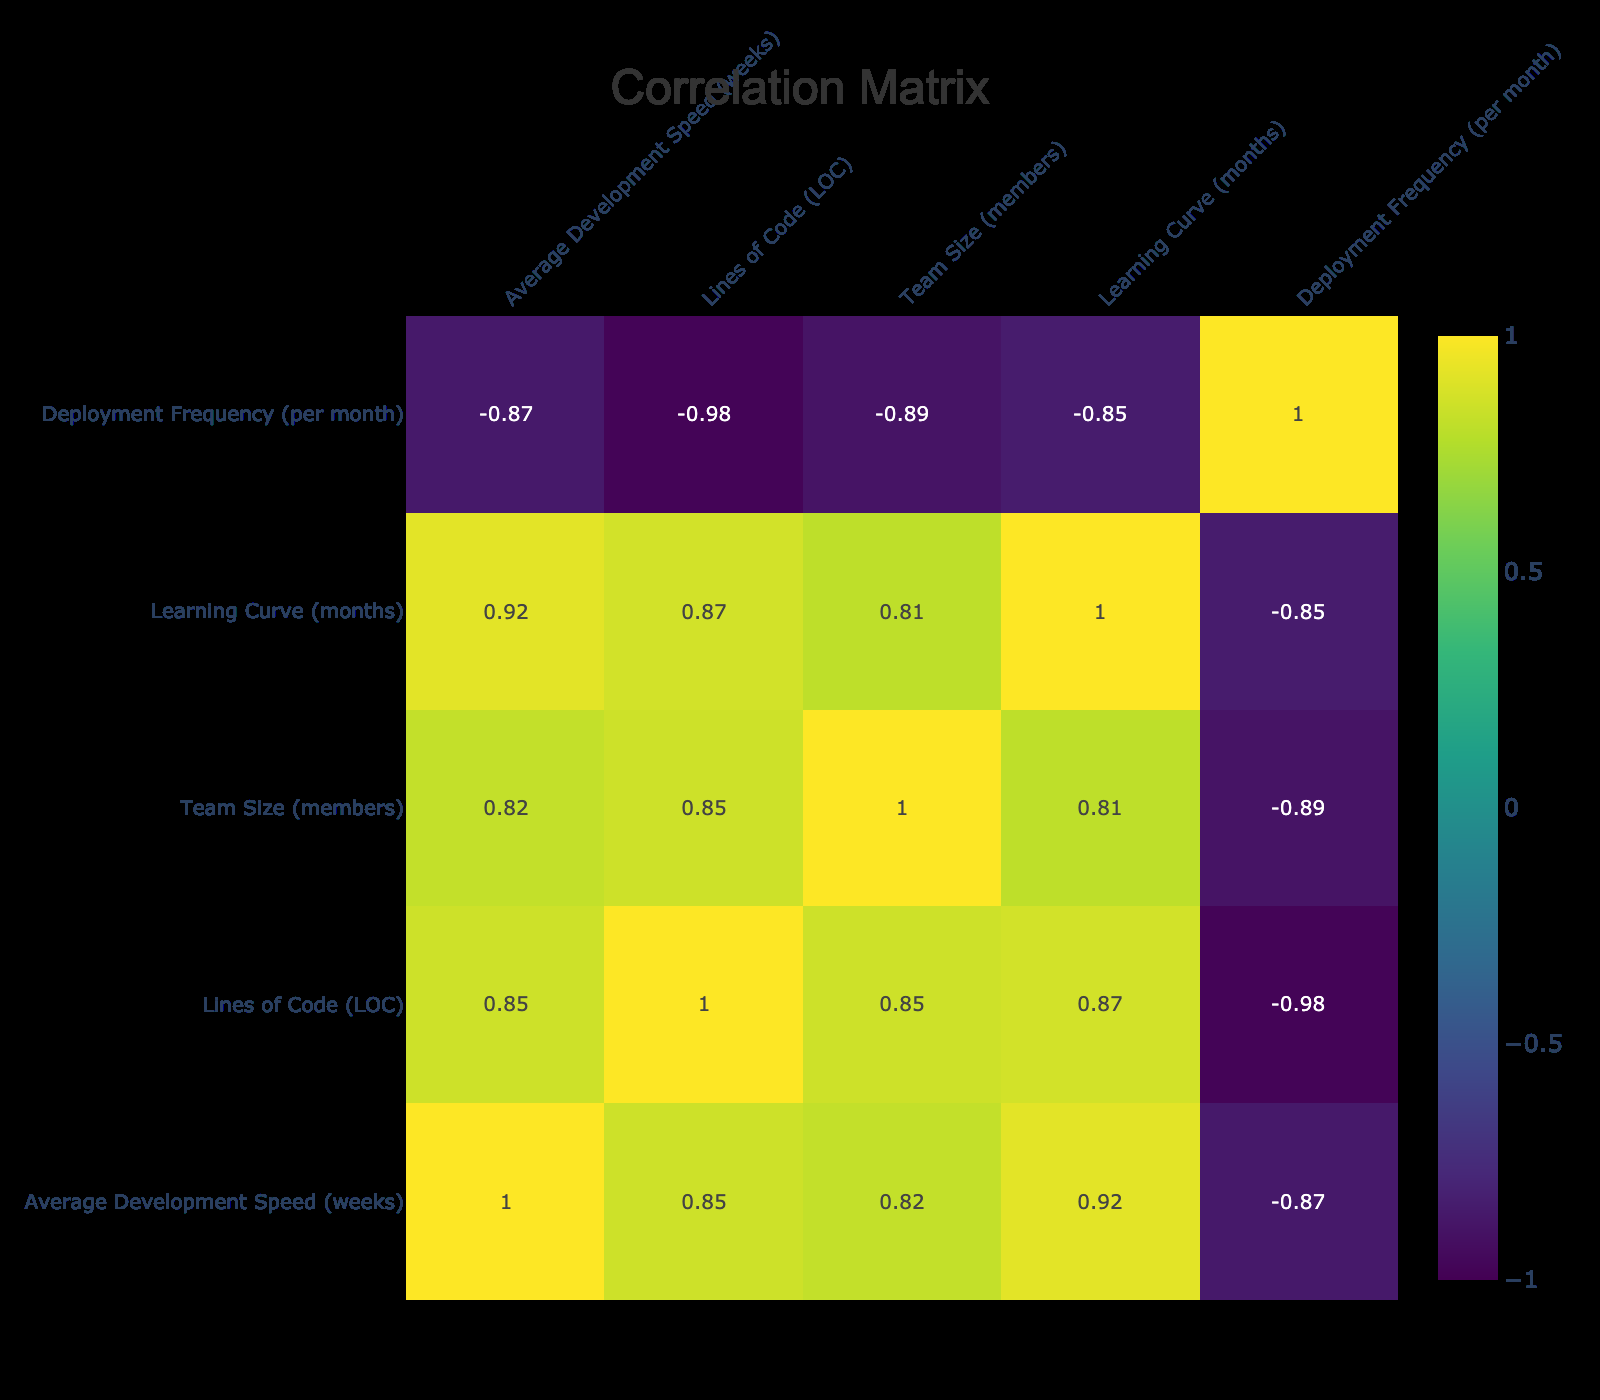What is the Framework with the highest Average Development Speed? By reviewing the table, we look for the row with the highest value in the "Average Development Speed" column. The highest value is 10, which corresponds to the 'Spring Boot' framework.
Answer: Spring Boot What is the correlation between Lines of Code and Average Development Speed? We examine the correlation table to find the value in the intersection of "Lines of Code" and "Average Development Speed." The correlation value is negative, specifically around -0.2, indicating a slight inverse relationship.
Answer: Negative correlation Which Framework has the second lowest Learning Curve? In the table, we can identify the "Learning Curve" values and sort them to find that 'React' and 'Vue.js' both have a learning curve of 1 month, but since 'Vue.js' appears to have the second lower entry, the answer is 'Vue.js'.
Answer: Vue.js What is the average deployment frequency of all frameworks? To find the average deployment frequency, we sum all the "Deployment Frequency" values: (8 + 6 + 10 + 7 + 5 + 4 + 12 + 5 + 9 + 15) which equals 81, and then divide by the number of frameworks (10), resulting in 8.1.
Answer: 8.1 Is there any framework with a Development Speed of less than 6 weeks? We evaluate the "Average Development Speed" column for values less than 6. The frameworks that satisfy this condition are 'Vue.js' and 'Express.js' (both are less than 6 weeks). Hence, the answer is yes.
Answer: Yes If we compare the Team Size between 'Ruby on Rails' and 'Django', which one has a greater difference in average Development Speed? We first look at their average development speeds: 'Ruby on Rails' has 9 weeks and 'Django' has 7 weeks, giving us a difference of 2 weeks. Hence, the answer states the greater difference in speed is 2 weeks.
Answer: 2 weeks What is the framework with the highest lines of code for a team of 5 members? By filtering the frameworks with a team size of 5, we find 'React' with 1500 lines of code and 'ASP.NET,' also with 2100 lines of code, but 'ASP.NET' remains higher in our context, thus the answer is 'ASP.NET.'
Answer: ASP.NET How many frameworks have a Learning Curve longer than 2 months? We look at the "Learning Curve" column and see frameworks like 'Angular,' 'Ruby on Rails,' and 'Spring Boot,' each having a learning curve longer than 2 months. Thus there are three frameworks that meet this condition.
Answer: 3 